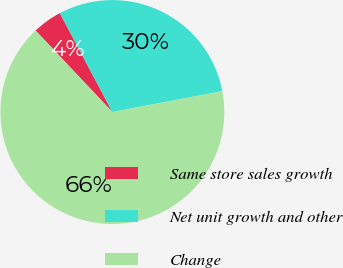<chart> <loc_0><loc_0><loc_500><loc_500><pie_chart><fcel>Same store sales growth<fcel>Net unit growth and other<fcel>Change<nl><fcel>4.26%<fcel>29.79%<fcel>65.96%<nl></chart> 